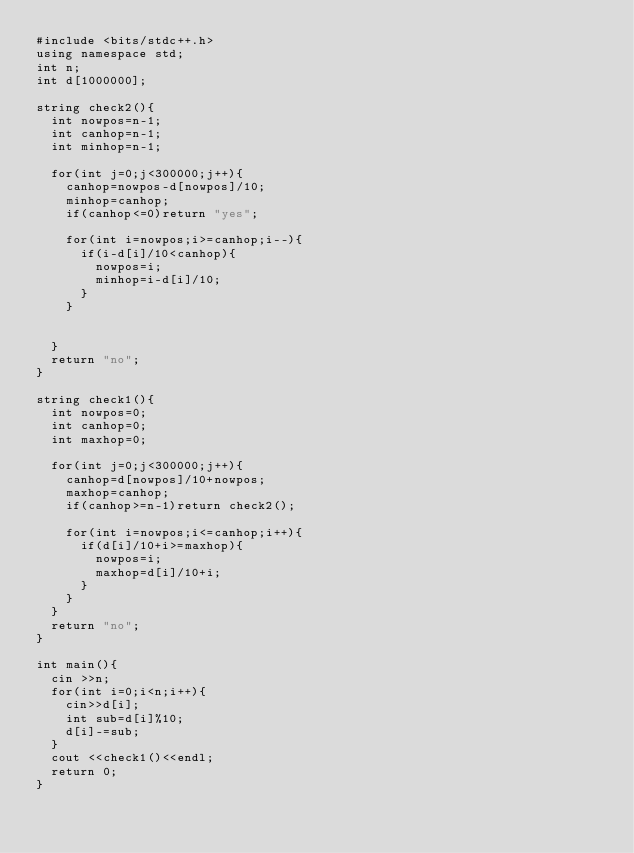Convert code to text. <code><loc_0><loc_0><loc_500><loc_500><_C++_>#include <bits/stdc++.h>
using namespace std;
int n;
int d[1000000];

string check2(){
  int nowpos=n-1;
  int canhop=n-1;
  int minhop=n-1;

  for(int j=0;j<300000;j++){
    canhop=nowpos-d[nowpos]/10;
    minhop=canhop;
    if(canhop<=0)return "yes";

    for(int i=nowpos;i>=canhop;i--){
      if(i-d[i]/10<canhop){
        nowpos=i;
        minhop=i-d[i]/10;
      }
    }


  }
  return "no";
}

string check1(){
  int nowpos=0;
  int canhop=0;
  int maxhop=0;

  for(int j=0;j<300000;j++){
    canhop=d[nowpos]/10+nowpos;
    maxhop=canhop;
    if(canhop>=n-1)return check2();

    for(int i=nowpos;i<=canhop;i++){
      if(d[i]/10+i>=maxhop){
        nowpos=i;
        maxhop=d[i]/10+i;
      }
    }
  }
  return "no";
}

int main(){
  cin >>n;
  for(int i=0;i<n;i++){
    cin>>d[i];
    int sub=d[i]%10;
    d[i]-=sub;
  }
  cout <<check1()<<endl;
  return 0;
}</code> 